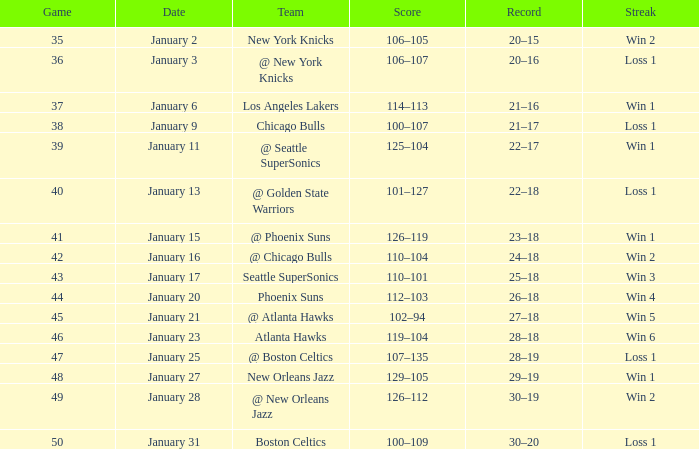What Game had a Score of 129–105? 48.0. 